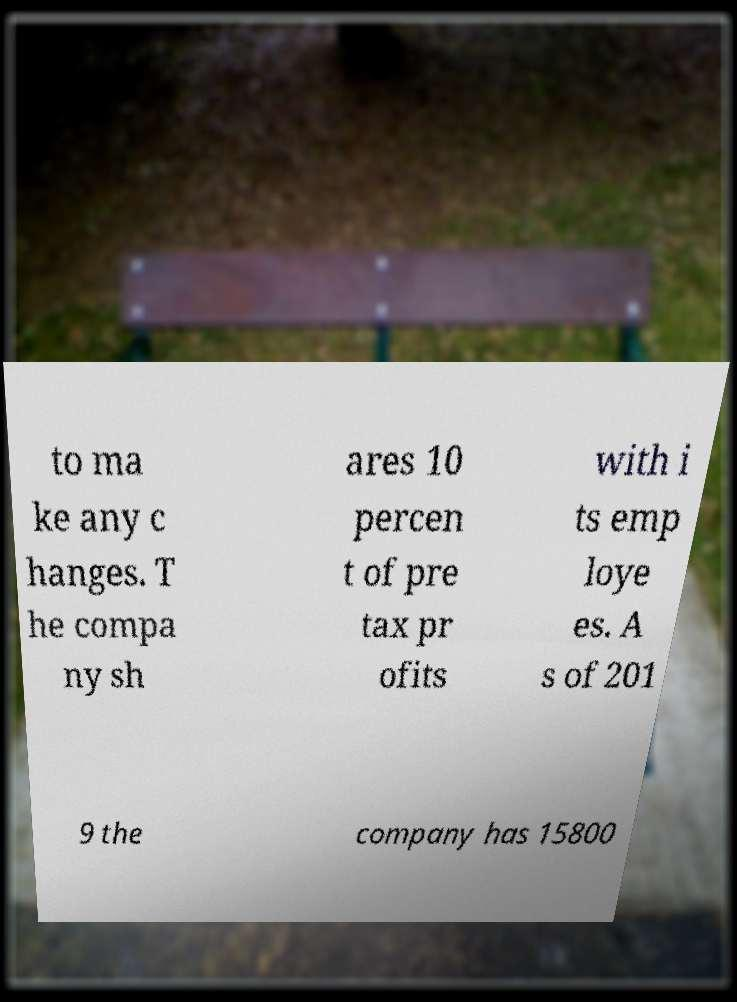Please identify and transcribe the text found in this image. to ma ke any c hanges. T he compa ny sh ares 10 percen t of pre tax pr ofits with i ts emp loye es. A s of 201 9 the company has 15800 